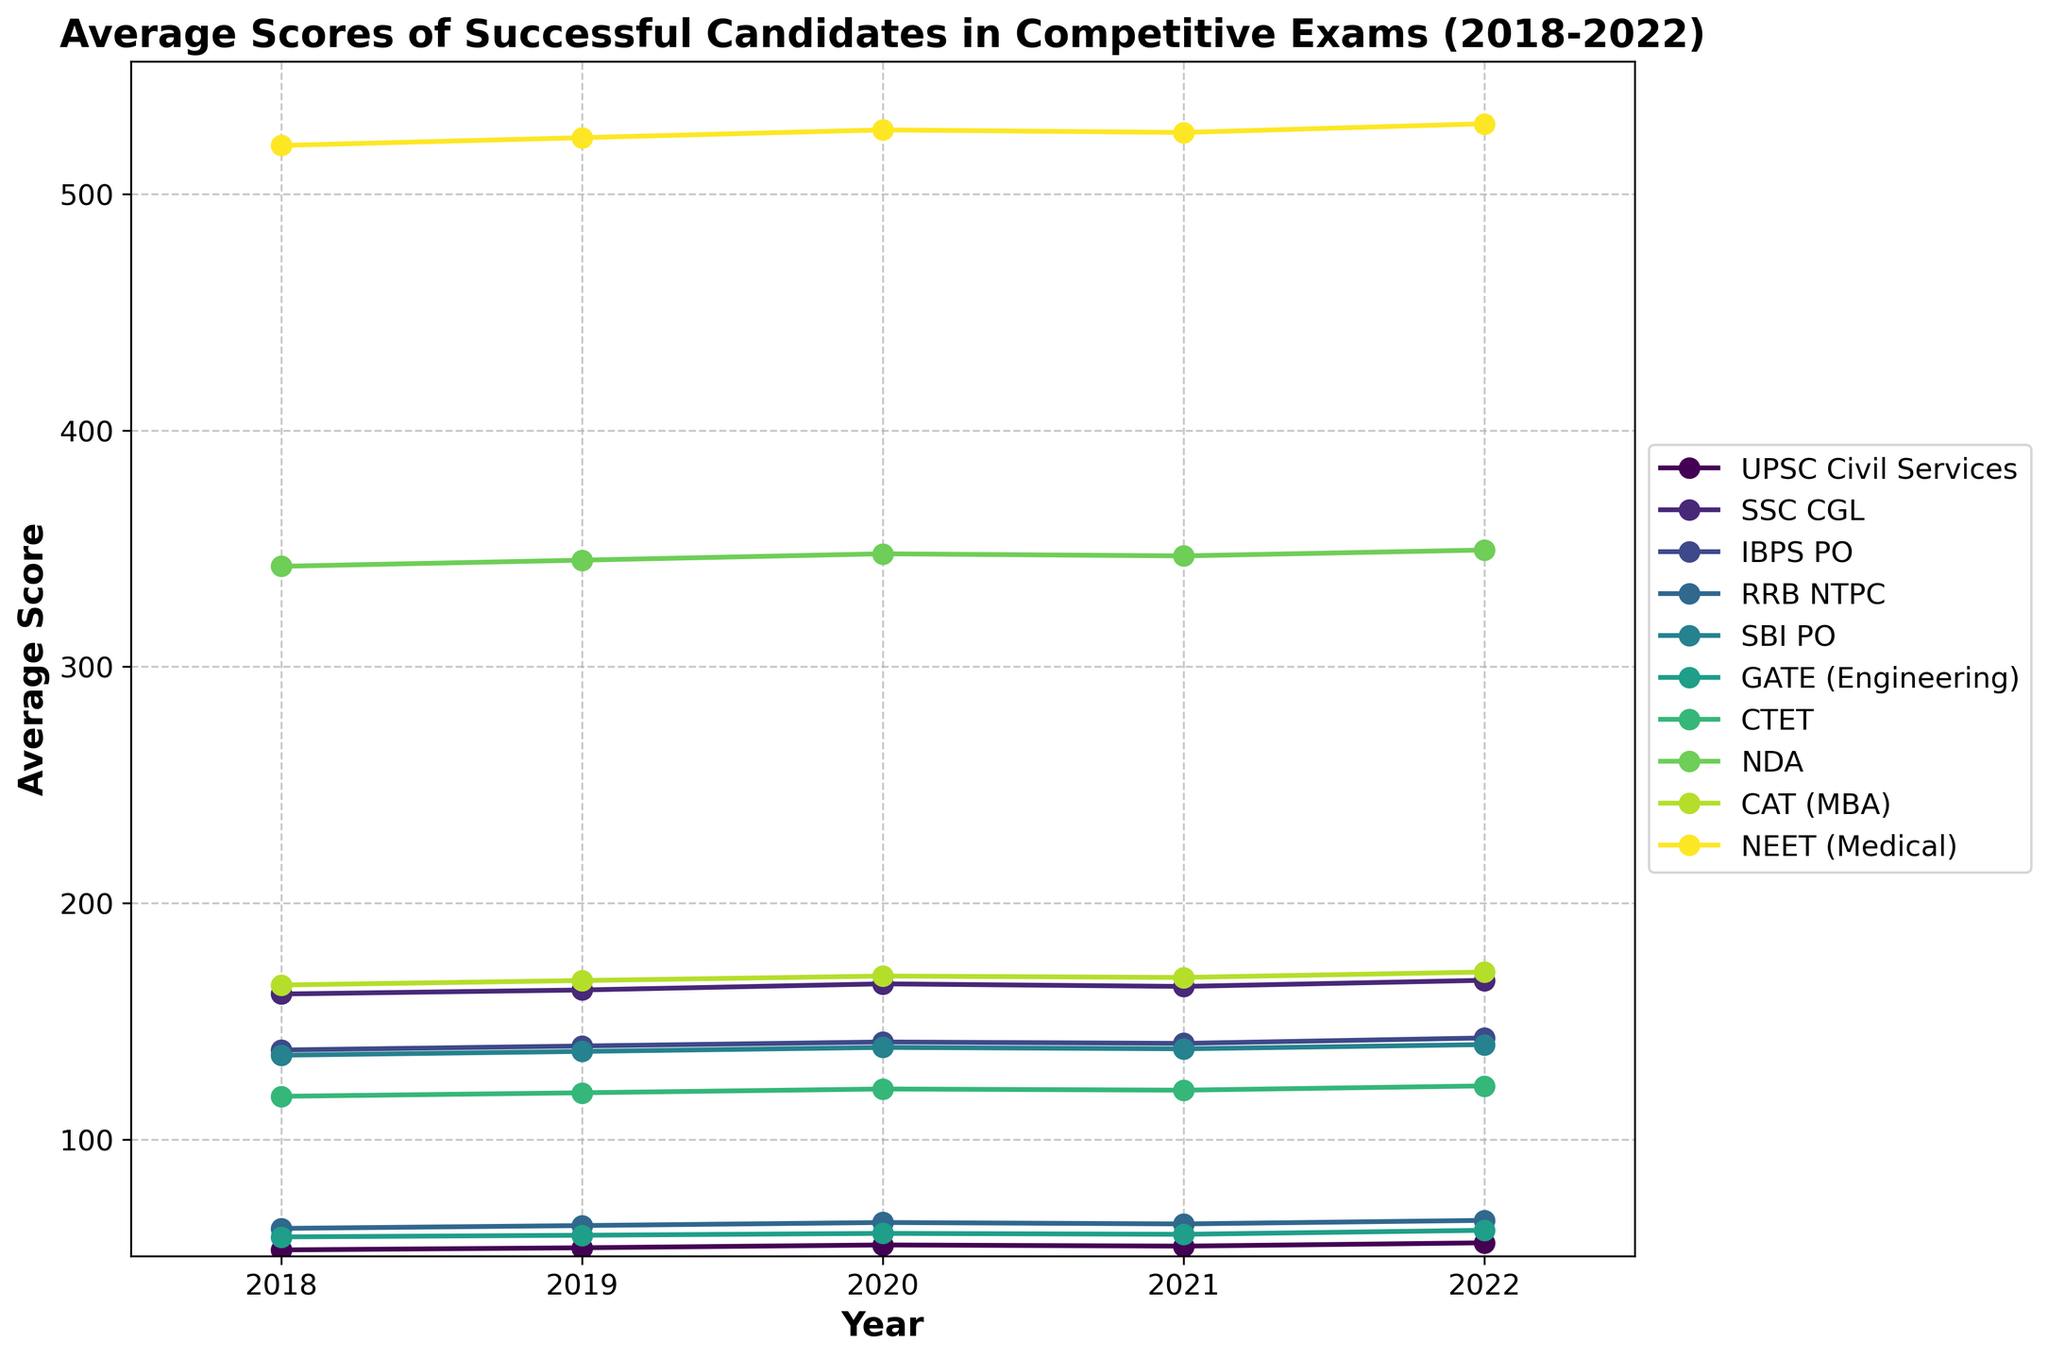Which exam shows the highest average score in 2022? To find the highest average score for 2022, identify the peak value among the 2022 data points across all exams. The highest score for 2022 is observed in NEET (Medical) with 529.8.
Answer: NEET (Medical) Which exams have shown a consistent increase in average scores from 2018 to 2022? By examining the trends, SSC CGL, IBPS PO, RRB NTPC, GATE (Engineering), CTET, NDA, CAT (MBA), and NEET (Medical) all show a consistent upward trend in their scores from 2018 to 2022.
Answer: SSC CGL, IBPS PO, RRB NTPC, GATE (Engineering), CTET, NDA, CAT (MBA), NEET (Medical) By how many points did the average score of the UPSC Civil Services exam change between 2018 and 2022? Calculate the difference between the 2022 and 2018 scores for the UPSC Civil Services exam: 56.2 - 53.2 = 3.0.
Answer: 3.0 In which year did the SBI PO average score see its largest increase compared to the previous year? Examine year-over-year changes for SBI PO and identify the largest increase. The increase from 2018 (135.6) to 2019 (137.2) is the highest, amounting to 1.6 points.
Answer: 2019 Which exam had the smallest average score increase from 2018 to 2022? Calculate the total score increase for each exam from 2018 to 2022 and identify the smallest increase. GATE (Engineering) had an increase of 2.8 points (61.5 - 58.7) which is the smallest.
Answer: GATE (Engineering) How does the average score of SSC CGL in 2021 compare to that in 2020 and 2022? Compare the average scores for SSC CGL across these years: 2021 (164.7), 2020 (165.8), and 2022 (167.3). The score in 2021 is lower than both 2020 and 2022.
Answer: Lower What is the combined average score increase for all exams from 2018 to 2022? Calculate the increase for each exam from 2018 to 2022, then sum these increases: 3.0 (UPSC) + 5.8 (SSC CGL) + 5.1 (IBPS PO) + 3.4 (RRB NTPC) + 4.5 (SBI PO) + 2.8 (GATE) + 4.4 (CTET) + 6.9 (NDA) + 5.5 (CAT) + 9.2 (NEET) = 50.6.
Answer: 50.6 Which exam had the most significant drop in average score from 2020 to 2021? Compare the changes in scores from 2020 to 2021 for each exam and identify the largest decrease. The UPSC Civil Services dropped by 0.5 points (55.3 to 54.8), which is the largest drop.
Answer: UPSC Civil Services 